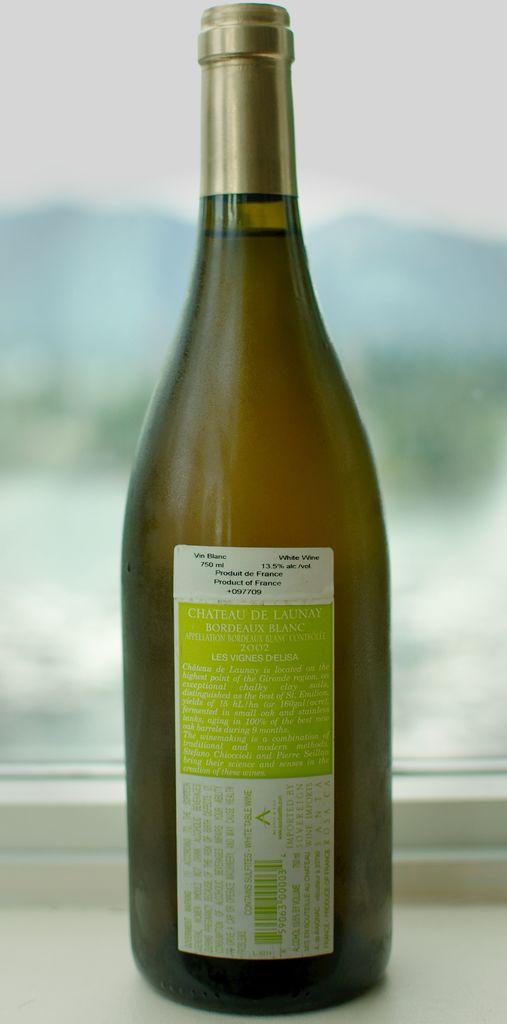What type of wine is in this bottle according to the label?
Provide a succinct answer. White wine. 